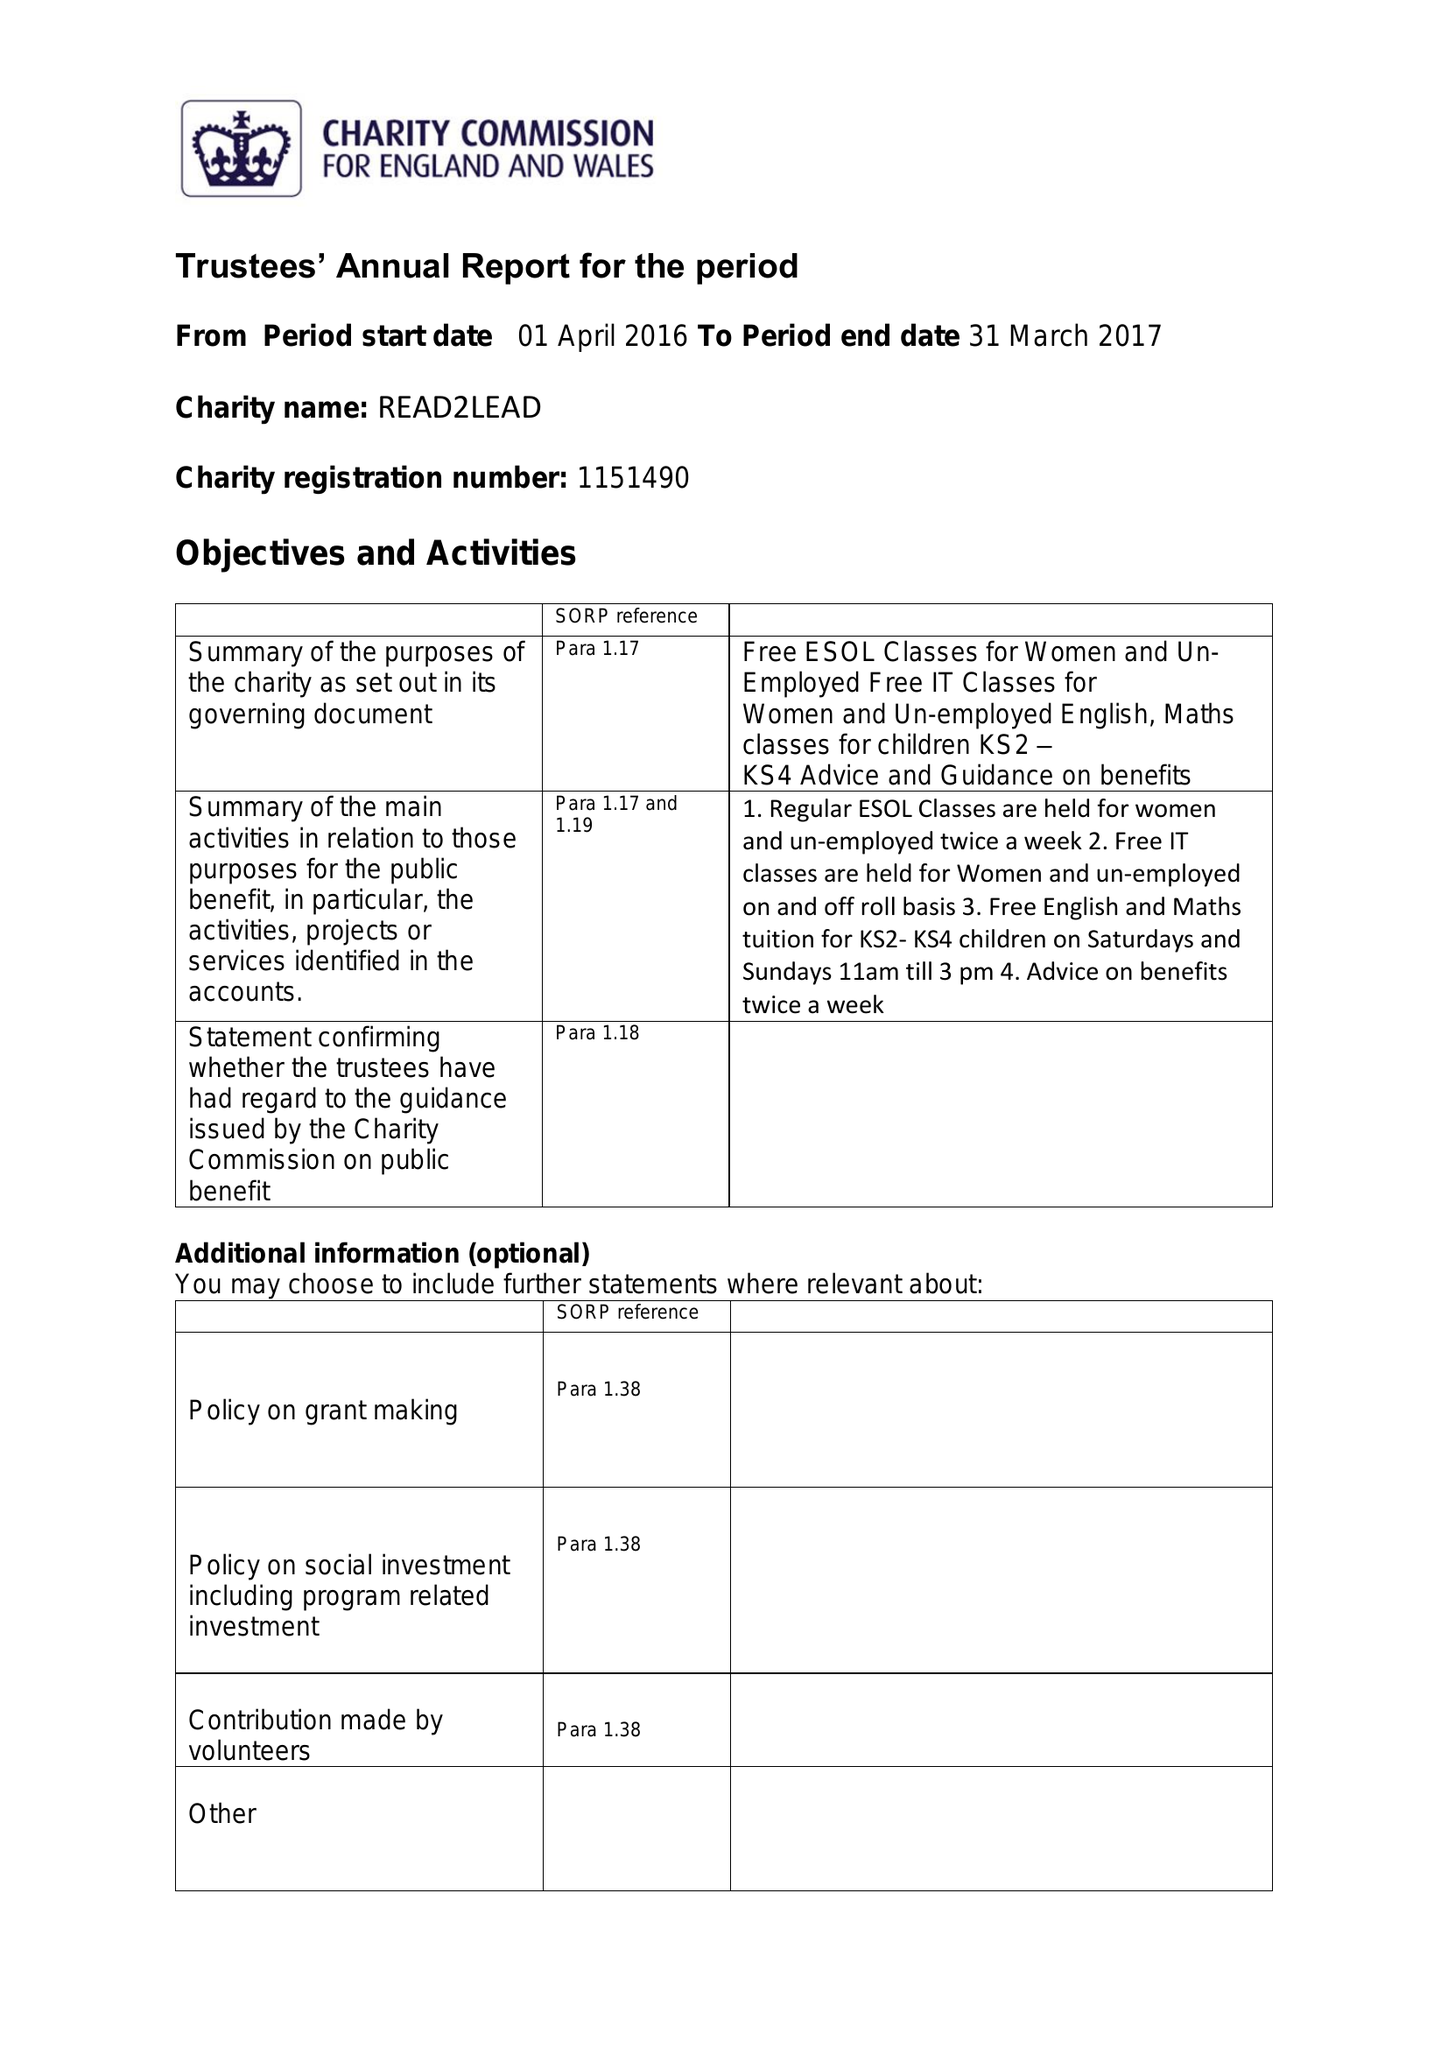What is the value for the address__post_town?
Answer the question using a single word or phrase. BIRMINGHAM 